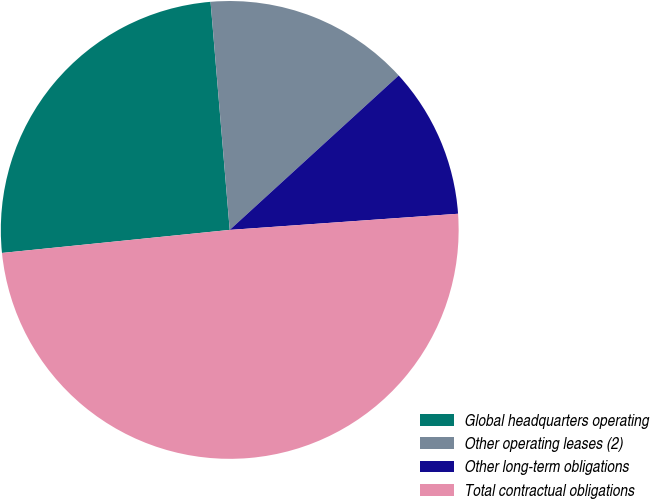Convert chart. <chart><loc_0><loc_0><loc_500><loc_500><pie_chart><fcel>Global headquarters operating<fcel>Other operating leases (2)<fcel>Other long-term obligations<fcel>Total contractual obligations<nl><fcel>25.27%<fcel>14.55%<fcel>10.66%<fcel>49.52%<nl></chart> 